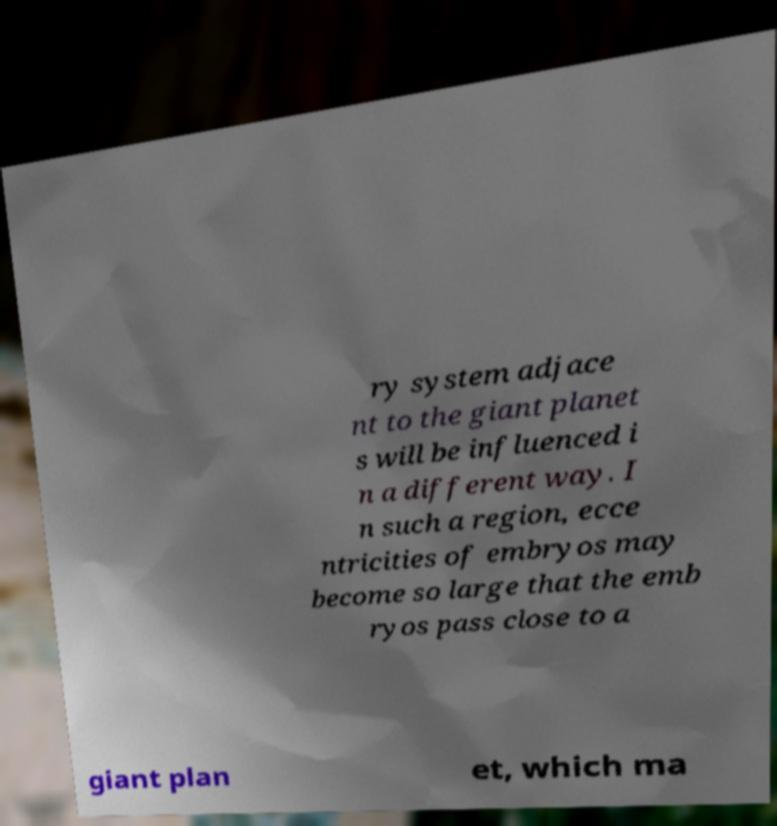Can you read and provide the text displayed in the image?This photo seems to have some interesting text. Can you extract and type it out for me? ry system adjace nt to the giant planet s will be influenced i n a different way. I n such a region, ecce ntricities of embryos may become so large that the emb ryos pass close to a giant plan et, which ma 